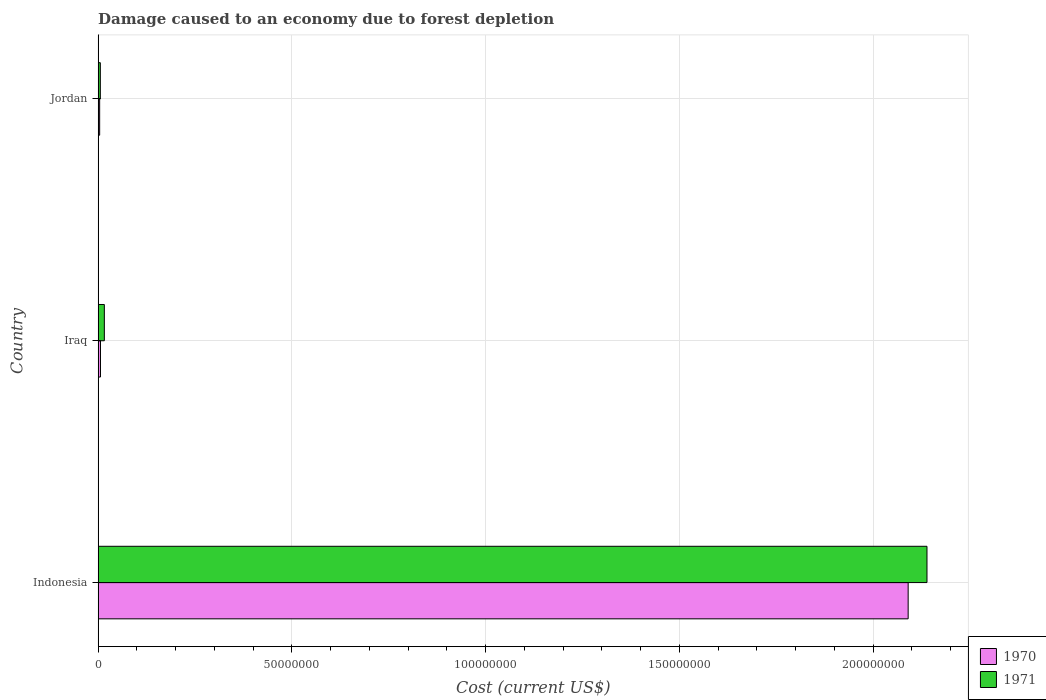How many groups of bars are there?
Ensure brevity in your answer.  3. Are the number of bars per tick equal to the number of legend labels?
Offer a terse response. Yes. Are the number of bars on each tick of the Y-axis equal?
Provide a succinct answer. Yes. How many bars are there on the 1st tick from the top?
Ensure brevity in your answer.  2. How many bars are there on the 1st tick from the bottom?
Make the answer very short. 2. What is the label of the 1st group of bars from the top?
Give a very brief answer. Jordan. In how many cases, is the number of bars for a given country not equal to the number of legend labels?
Provide a short and direct response. 0. What is the cost of damage caused due to forest depletion in 1971 in Jordan?
Your response must be concise. 5.72e+05. Across all countries, what is the maximum cost of damage caused due to forest depletion in 1970?
Offer a terse response. 2.09e+08. Across all countries, what is the minimum cost of damage caused due to forest depletion in 1970?
Your response must be concise. 3.97e+05. In which country was the cost of damage caused due to forest depletion in 1970 minimum?
Offer a very short reply. Jordan. What is the total cost of damage caused due to forest depletion in 1971 in the graph?
Make the answer very short. 2.16e+08. What is the difference between the cost of damage caused due to forest depletion in 1971 in Indonesia and that in Jordan?
Offer a terse response. 2.13e+08. What is the difference between the cost of damage caused due to forest depletion in 1970 in Indonesia and the cost of damage caused due to forest depletion in 1971 in Jordan?
Your response must be concise. 2.09e+08. What is the average cost of damage caused due to forest depletion in 1971 per country?
Give a very brief answer. 7.20e+07. What is the difference between the cost of damage caused due to forest depletion in 1970 and cost of damage caused due to forest depletion in 1971 in Jordan?
Keep it short and to the point. -1.74e+05. In how many countries, is the cost of damage caused due to forest depletion in 1971 greater than 190000000 US$?
Make the answer very short. 1. What is the ratio of the cost of damage caused due to forest depletion in 1971 in Iraq to that in Jordan?
Your response must be concise. 2.81. Is the cost of damage caused due to forest depletion in 1971 in Indonesia less than that in Iraq?
Offer a very short reply. No. What is the difference between the highest and the second highest cost of damage caused due to forest depletion in 1971?
Your answer should be very brief. 2.12e+08. What is the difference between the highest and the lowest cost of damage caused due to forest depletion in 1970?
Keep it short and to the point. 2.09e+08. In how many countries, is the cost of damage caused due to forest depletion in 1971 greater than the average cost of damage caused due to forest depletion in 1971 taken over all countries?
Provide a succinct answer. 1. What does the 2nd bar from the bottom in Indonesia represents?
Your answer should be compact. 1971. How many countries are there in the graph?
Your answer should be very brief. 3. What is the difference between two consecutive major ticks on the X-axis?
Keep it short and to the point. 5.00e+07. Does the graph contain any zero values?
Ensure brevity in your answer.  No. How are the legend labels stacked?
Offer a very short reply. Vertical. What is the title of the graph?
Provide a succinct answer. Damage caused to an economy due to forest depletion. What is the label or title of the X-axis?
Give a very brief answer. Cost (current US$). What is the Cost (current US$) in 1970 in Indonesia?
Make the answer very short. 2.09e+08. What is the Cost (current US$) of 1971 in Indonesia?
Offer a terse response. 2.14e+08. What is the Cost (current US$) in 1970 in Iraq?
Your answer should be very brief. 6.13e+05. What is the Cost (current US$) in 1971 in Iraq?
Make the answer very short. 1.60e+06. What is the Cost (current US$) of 1970 in Jordan?
Your answer should be very brief. 3.97e+05. What is the Cost (current US$) in 1971 in Jordan?
Offer a very short reply. 5.72e+05. Across all countries, what is the maximum Cost (current US$) in 1970?
Your response must be concise. 2.09e+08. Across all countries, what is the maximum Cost (current US$) of 1971?
Make the answer very short. 2.14e+08. Across all countries, what is the minimum Cost (current US$) of 1970?
Your answer should be very brief. 3.97e+05. Across all countries, what is the minimum Cost (current US$) in 1971?
Provide a short and direct response. 5.72e+05. What is the total Cost (current US$) in 1970 in the graph?
Make the answer very short. 2.10e+08. What is the total Cost (current US$) in 1971 in the graph?
Keep it short and to the point. 2.16e+08. What is the difference between the Cost (current US$) of 1970 in Indonesia and that in Iraq?
Offer a very short reply. 2.08e+08. What is the difference between the Cost (current US$) in 1971 in Indonesia and that in Iraq?
Give a very brief answer. 2.12e+08. What is the difference between the Cost (current US$) in 1970 in Indonesia and that in Jordan?
Give a very brief answer. 2.09e+08. What is the difference between the Cost (current US$) of 1971 in Indonesia and that in Jordan?
Keep it short and to the point. 2.13e+08. What is the difference between the Cost (current US$) in 1970 in Iraq and that in Jordan?
Your answer should be very brief. 2.15e+05. What is the difference between the Cost (current US$) in 1971 in Iraq and that in Jordan?
Offer a very short reply. 1.03e+06. What is the difference between the Cost (current US$) of 1970 in Indonesia and the Cost (current US$) of 1971 in Iraq?
Keep it short and to the point. 2.07e+08. What is the difference between the Cost (current US$) of 1970 in Indonesia and the Cost (current US$) of 1971 in Jordan?
Your answer should be very brief. 2.09e+08. What is the difference between the Cost (current US$) of 1970 in Iraq and the Cost (current US$) of 1971 in Jordan?
Keep it short and to the point. 4.11e+04. What is the average Cost (current US$) of 1970 per country?
Provide a succinct answer. 7.00e+07. What is the average Cost (current US$) in 1971 per country?
Your response must be concise. 7.20e+07. What is the difference between the Cost (current US$) of 1970 and Cost (current US$) of 1971 in Indonesia?
Provide a succinct answer. -4.86e+06. What is the difference between the Cost (current US$) in 1970 and Cost (current US$) in 1971 in Iraq?
Keep it short and to the point. -9.92e+05. What is the difference between the Cost (current US$) in 1970 and Cost (current US$) in 1971 in Jordan?
Ensure brevity in your answer.  -1.74e+05. What is the ratio of the Cost (current US$) of 1970 in Indonesia to that in Iraq?
Your answer should be very brief. 341.28. What is the ratio of the Cost (current US$) of 1971 in Indonesia to that in Iraq?
Make the answer very short. 133.3. What is the ratio of the Cost (current US$) in 1970 in Indonesia to that in Jordan?
Your answer should be compact. 526.07. What is the ratio of the Cost (current US$) in 1971 in Indonesia to that in Jordan?
Give a very brief answer. 374.32. What is the ratio of the Cost (current US$) in 1970 in Iraq to that in Jordan?
Your response must be concise. 1.54. What is the ratio of the Cost (current US$) of 1971 in Iraq to that in Jordan?
Give a very brief answer. 2.81. What is the difference between the highest and the second highest Cost (current US$) of 1970?
Provide a succinct answer. 2.08e+08. What is the difference between the highest and the second highest Cost (current US$) of 1971?
Provide a short and direct response. 2.12e+08. What is the difference between the highest and the lowest Cost (current US$) in 1970?
Your answer should be compact. 2.09e+08. What is the difference between the highest and the lowest Cost (current US$) in 1971?
Ensure brevity in your answer.  2.13e+08. 